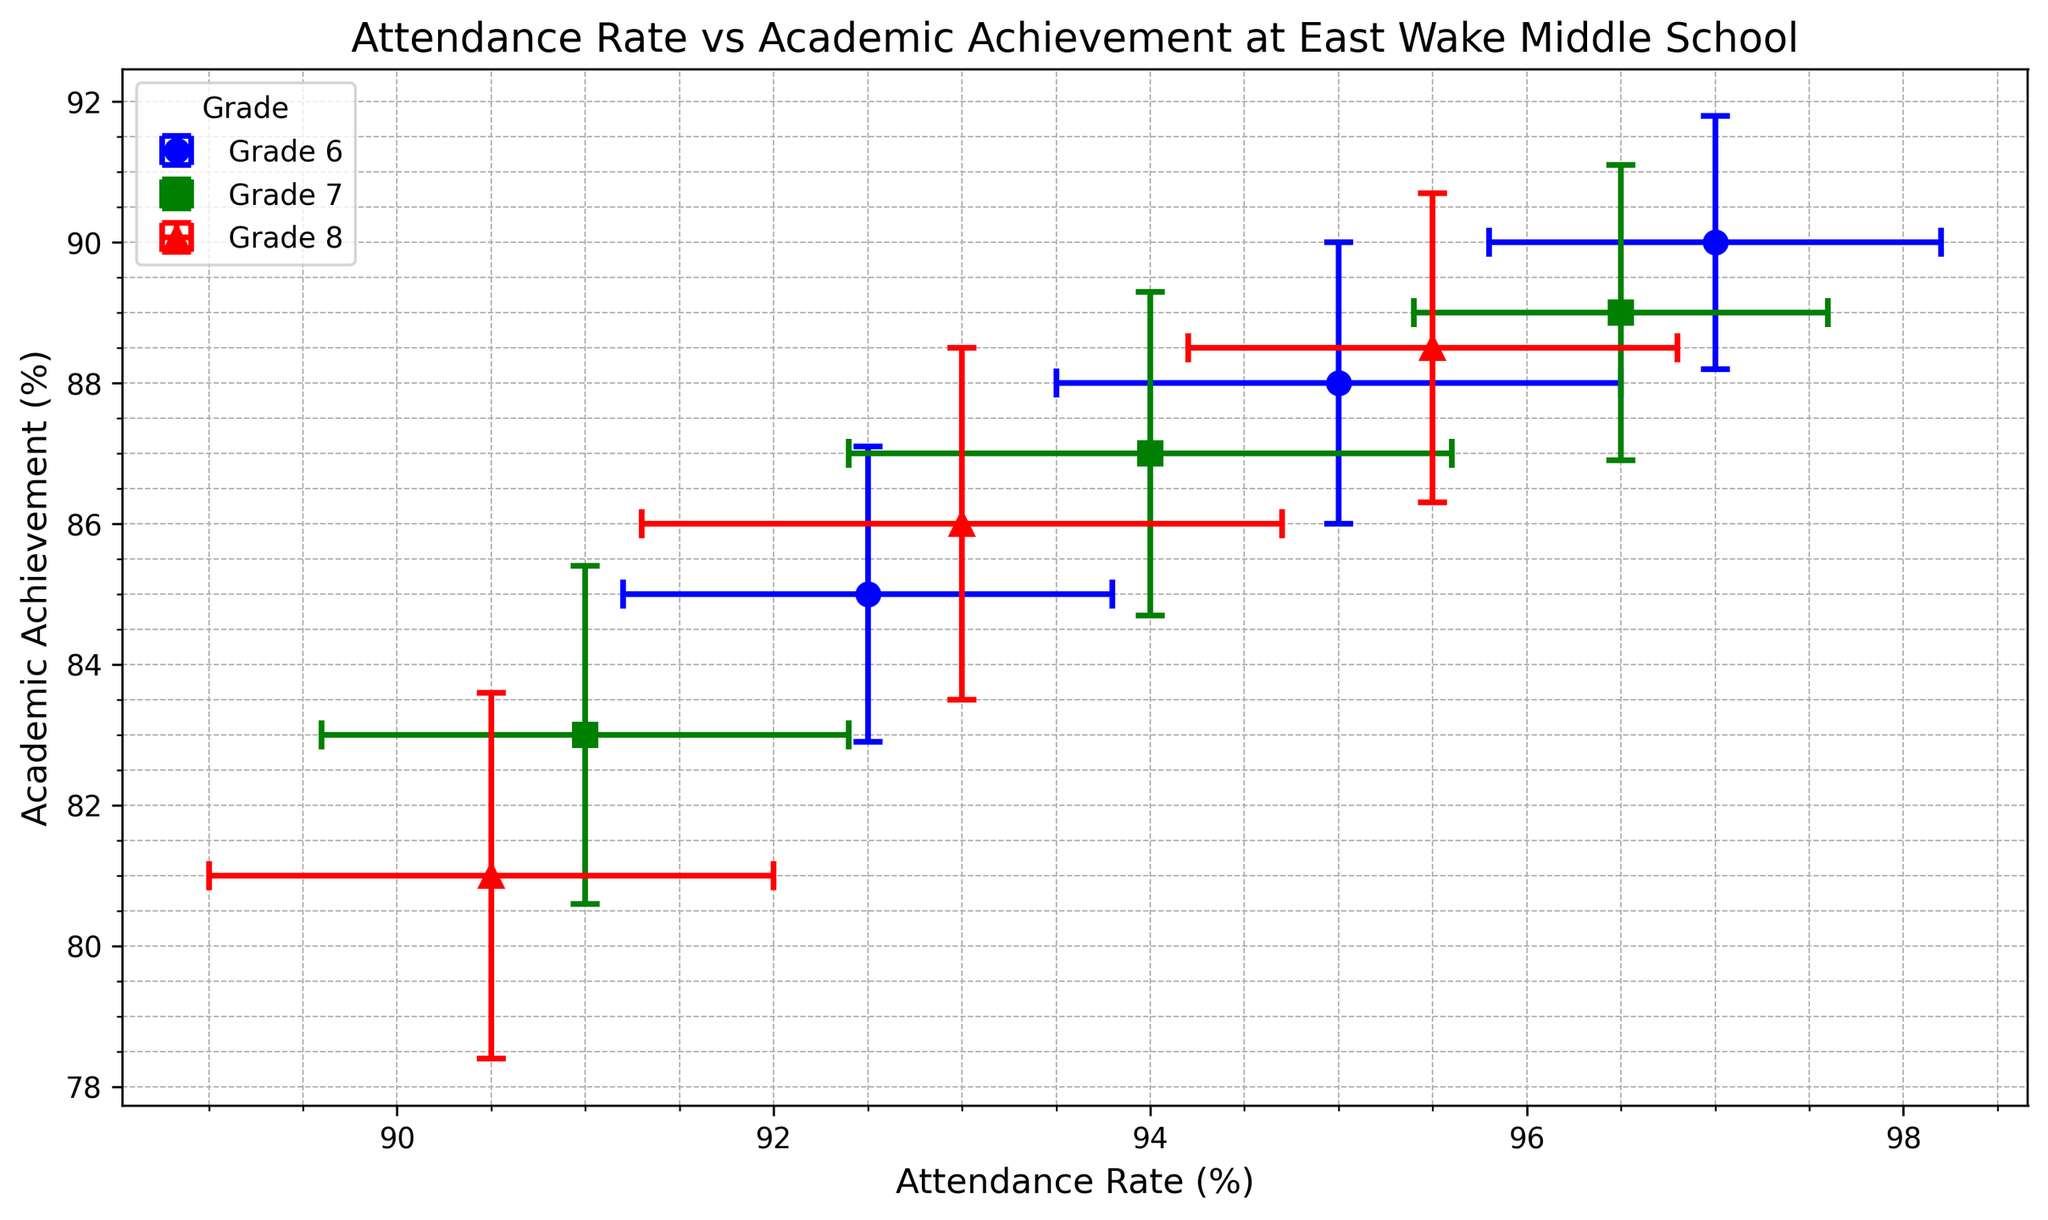What's the average attendance rate for Grade 6 students? There are three attendance rates for Grade 6: 95.0%, 92.5%, and 97.0%. Adding them up gives (95.0 + 92.5 + 97.0) = 284.5. Dividing this sum by 3 gives the average: 284.5 / 3 = 94.83%.
Answer: 94.83% Which grade has the highest average academic achievement? We need to calculate the average academic achievement for each grade. For Grade 6: (88.0 + 85.0 + 90.0) / 3 = 87.67%. For Grade 7: (87.0 + 83.0 + 89.0) / 3 = 86.33%. For Grade 8: (86.0 + 81.0 + 88.5) / 3 = 85.17%. Grade 6 has the highest average academic achievement at 87.67%.
Answer: Grade 6 How does the attendance rate of Grade 7 students compare to Grade 8? We compare the individual attendance rates: Grade 7 has rates of 94.0%, 91.0%, and 96.5%. Grade 8 has rates of 93.0%, 90.5%, and 95.5%. Clearly, Grade 7's attendance rates are consistently higher.
Answer: Grade 7 is higher Which data point has the smallest error bar for academic achievement? By visually comparing the length of the academic achievement error bars, we see that the smallest error bar is for Grade 6 with an 88.0% academic achievement (error = 1.8%).
Answer: Grade 6 (88.0%) What are the attendance rate and academic achievement of the Grade 8 student with the highest academic achievement? For Grade 8, the student with the highest academic achievement has an achievement rate of 88.5%. The corresponding attendance rate is 95.5%.
Answer: 95.5% attendance rate and 88.5% academic achievement What's the range of academic achievement percentage for Grade 7 students? The minimum academic achievement for Grade 7 is 83.0% and the maximum is 89.0%. Hence, the range is 89.0 - 83.0 = 6.0%.
Answer: 6.0% Compare the variation in attendance rates (considering error bars) between Grade 6 and Grade 8. The error bars for Grade 6 attendance rates are 1.5%, 1.3%, and 1.2%. For Grade 8, they are 1.7%, 1.5%, and 1.3%. Grade 8 generally has slightly larger error bars, indicating higher variation.
Answer: Grade 8 has higher variation Which grade has the highest variability in academic achievement as indicated by the error bars? The error bars for academic achievement for Grade 6 are 2.0%, 2.1%, and 1.8%. For Grade 7, they are 2.3%, 2.4%, and 2.1%. For Grade 8, they are 2.5%, 2.6%, and 2.2%. Grade 8 has the highest error bars, indicating the highest variability.
Answer: Grade 8 